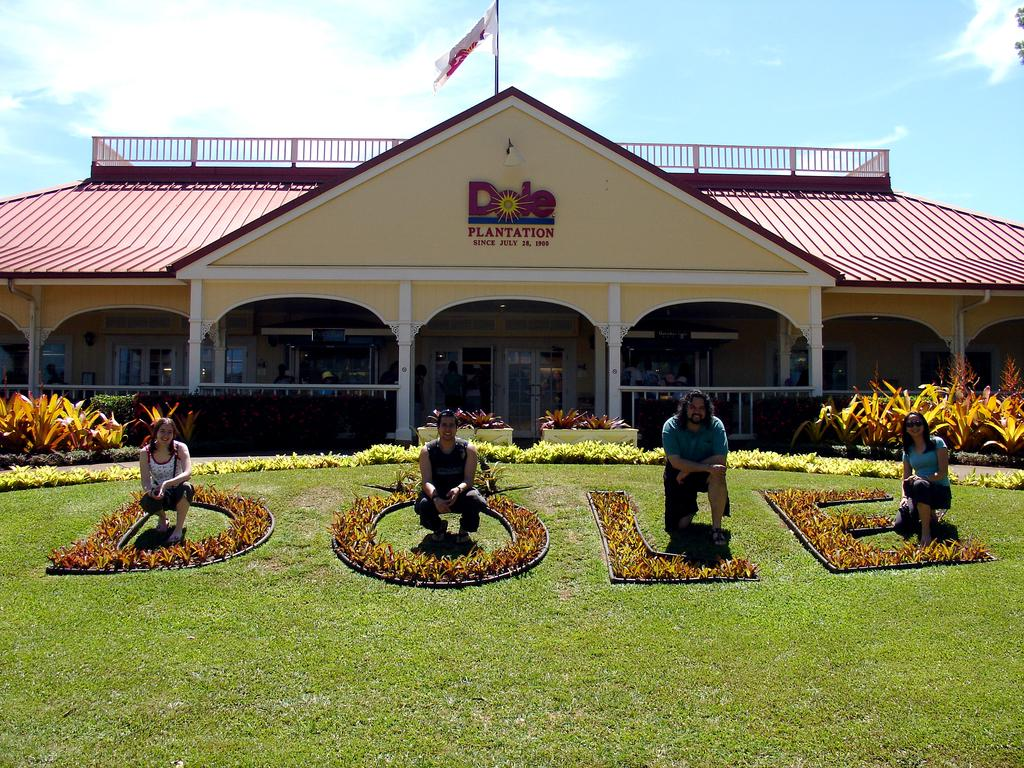What can be seen in the sky in the image? The sky with clouds is visible in the image. What is attached to the flag post in the image? There is a flag attached to the flag post in the image. What type of structure is present in the image? There is a building in the image. What type of vegetation is present in the image? There are bushes in the image. What are the people in the image doing? There are persons standing on the floor and sitting on the ground inquire about the actions and positions of the people in the image. What architectural feature is present in the image? Railings are present in the image. What is the condition of the persons' experience in the image? There is no information about the condition or experience of the persons in the image. What angle is the flag flying at in the image? The angle at which the flag is flying cannot be determined from the image. 